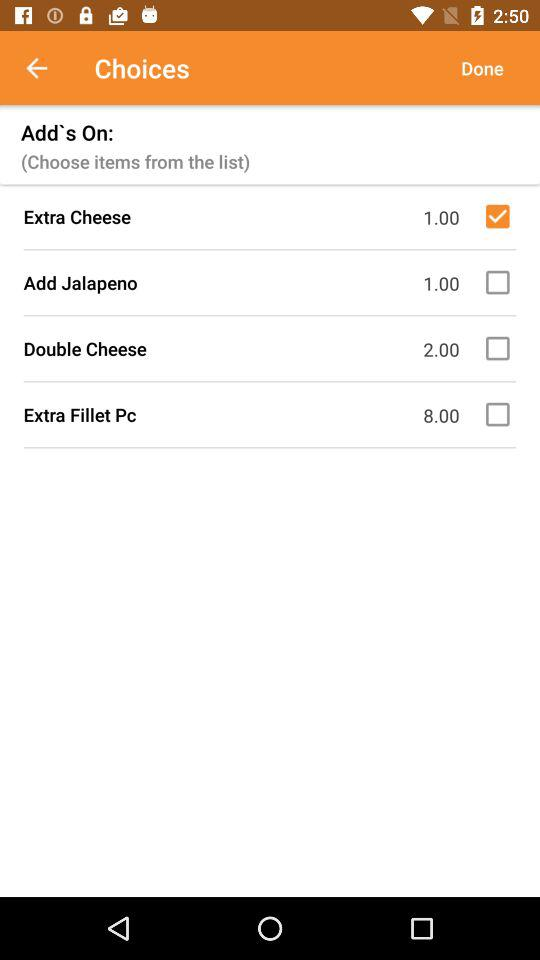Which add-on has been selected? The selected add-on is "Extra Cheese". 